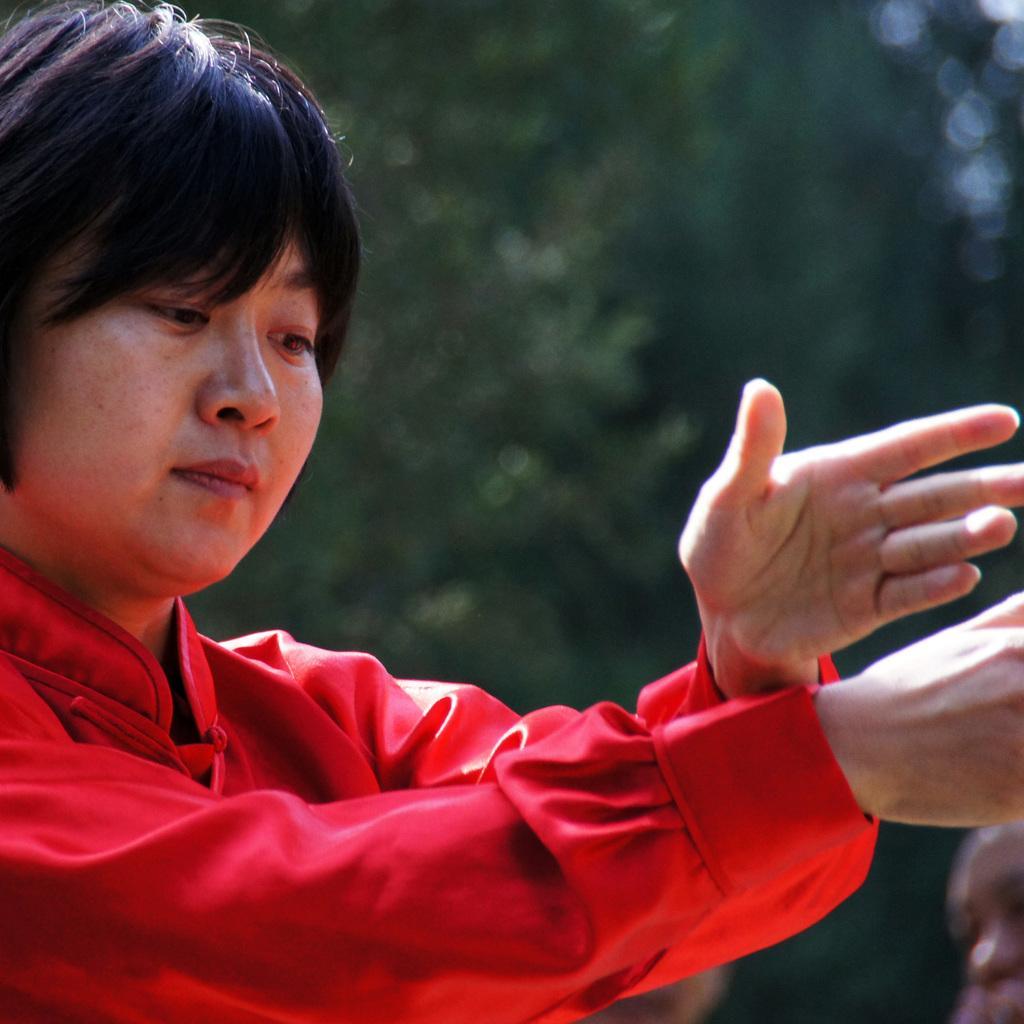Please provide a concise description of this image. To the left side of the image there is a person with red dress. There is a green color background. 